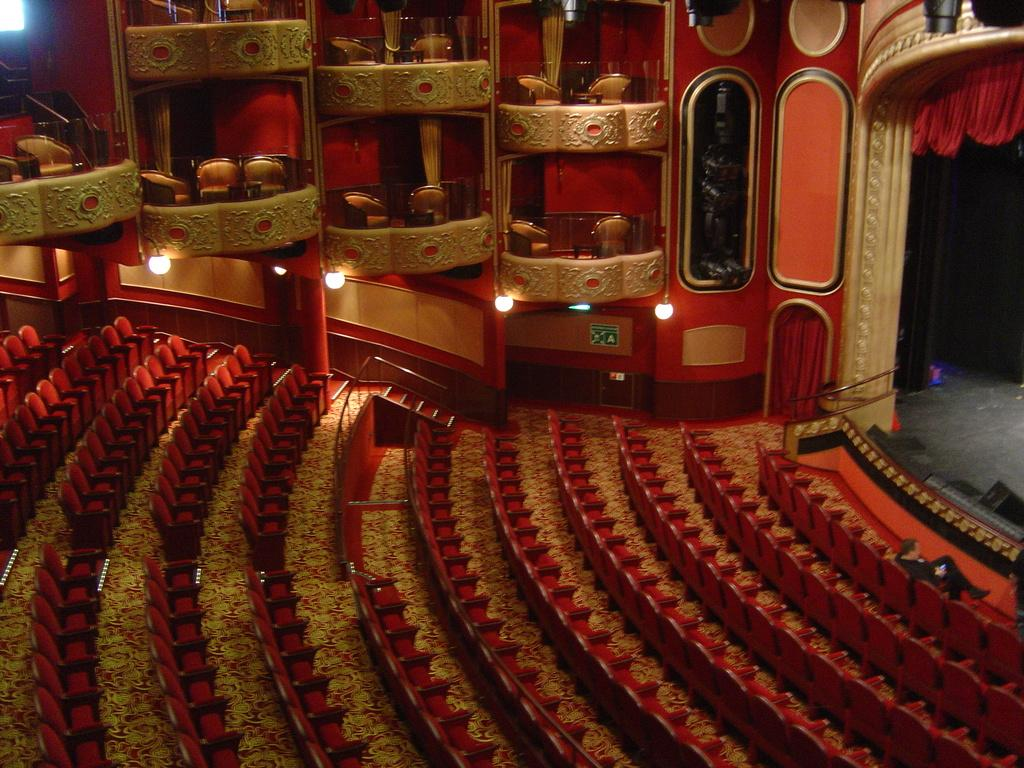What type of location is shown in the image? The image depicts a hall. How many seats are visible in the hall? There are many empty seats in the hall. Is there anyone sitting in the hall? Yes, there is a person sitting in the front row. What is the person doing in the image? The person is sitting on one of the seats. What can be seen in front of the person? There is a dais in front of the person. What type of protest is happening in the hall in the image? There is no protest happening in the hall in the image; it shows an empty hall with a person sitting in the front row. How many children are visible in the image? There are no children visible in the image; it only shows a person sitting in the hall. 